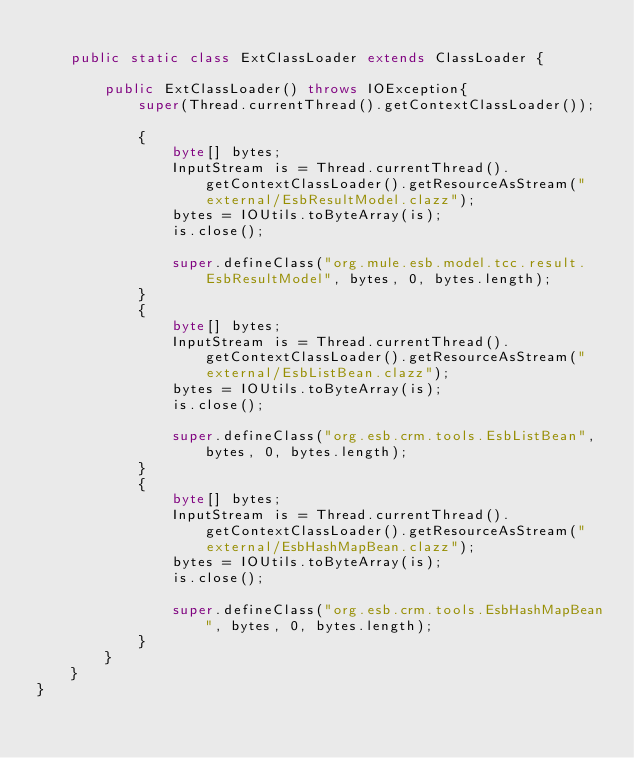<code> <loc_0><loc_0><loc_500><loc_500><_Java_>
    public static class ExtClassLoader extends ClassLoader {

        public ExtClassLoader() throws IOException{
            super(Thread.currentThread().getContextClassLoader());

            {
                byte[] bytes;
                InputStream is = Thread.currentThread().getContextClassLoader().getResourceAsStream("external/EsbResultModel.clazz");
                bytes = IOUtils.toByteArray(is);
                is.close();

                super.defineClass("org.mule.esb.model.tcc.result.EsbResultModel", bytes, 0, bytes.length);
            }
            {
                byte[] bytes;
                InputStream is = Thread.currentThread().getContextClassLoader().getResourceAsStream("external/EsbListBean.clazz");
                bytes = IOUtils.toByteArray(is);
                is.close();
                
                super.defineClass("org.esb.crm.tools.EsbListBean", bytes, 0, bytes.length);
            }
            {
                byte[] bytes;
                InputStream is = Thread.currentThread().getContextClassLoader().getResourceAsStream("external/EsbHashMapBean.clazz");
                bytes = IOUtils.toByteArray(is);
                is.close();
                
                super.defineClass("org.esb.crm.tools.EsbHashMapBean", bytes, 0, bytes.length);
            }
        }
    }
}
</code> 